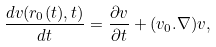Convert formula to latex. <formula><loc_0><loc_0><loc_500><loc_500>\frac { d { v } ( { r } _ { 0 } ( t ) , t ) } { d t } = \frac { \partial { v } } { \partial t } + ( { v } _ { 0 } . { \nabla } ) { v } ,</formula> 